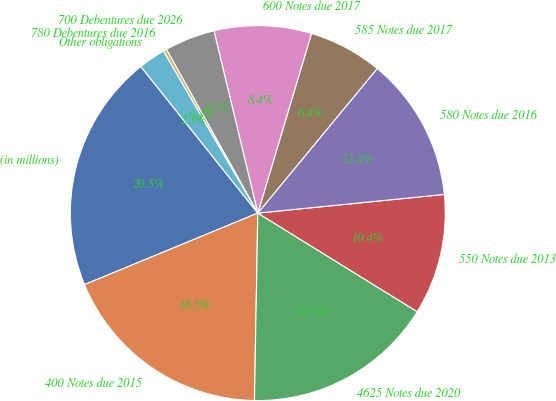Convert chart. <chart><loc_0><loc_0><loc_500><loc_500><pie_chart><fcel>(in millions)<fcel>400 Notes due 2015<fcel>4625 Notes due 2020<fcel>550 Notes due 2013<fcel>580 Notes due 2016<fcel>585 Notes due 2017<fcel>600 Notes due 2017<fcel>700 Debentures due 2026<fcel>780 Debentures due 2016<fcel>Other obligations<nl><fcel>20.5%<fcel>18.48%<fcel>16.46%<fcel>10.4%<fcel>12.42%<fcel>6.36%<fcel>8.38%<fcel>4.34%<fcel>0.3%<fcel>2.32%<nl></chart> 